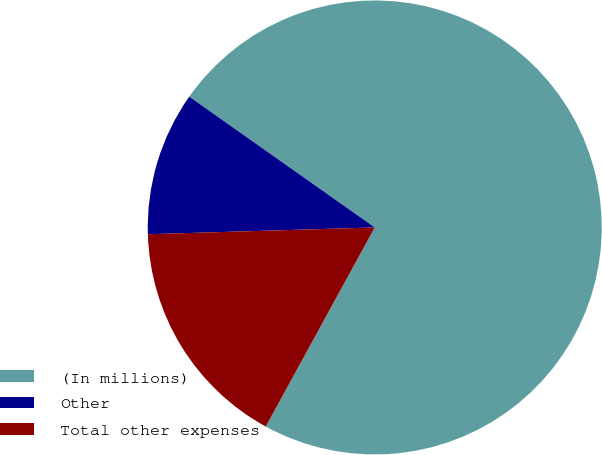Convert chart to OTSL. <chart><loc_0><loc_0><loc_500><loc_500><pie_chart><fcel>(In millions)<fcel>Other<fcel>Total other expenses<nl><fcel>73.2%<fcel>10.25%<fcel>16.55%<nl></chart> 